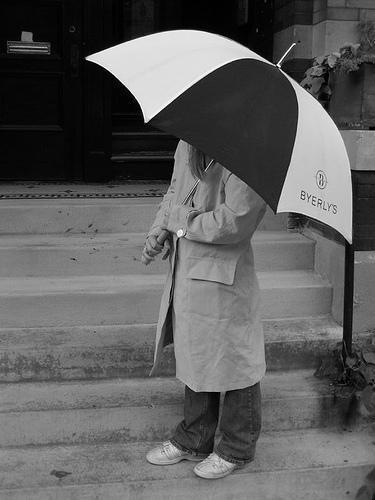How many steps are there?
Give a very brief answer. 5. 